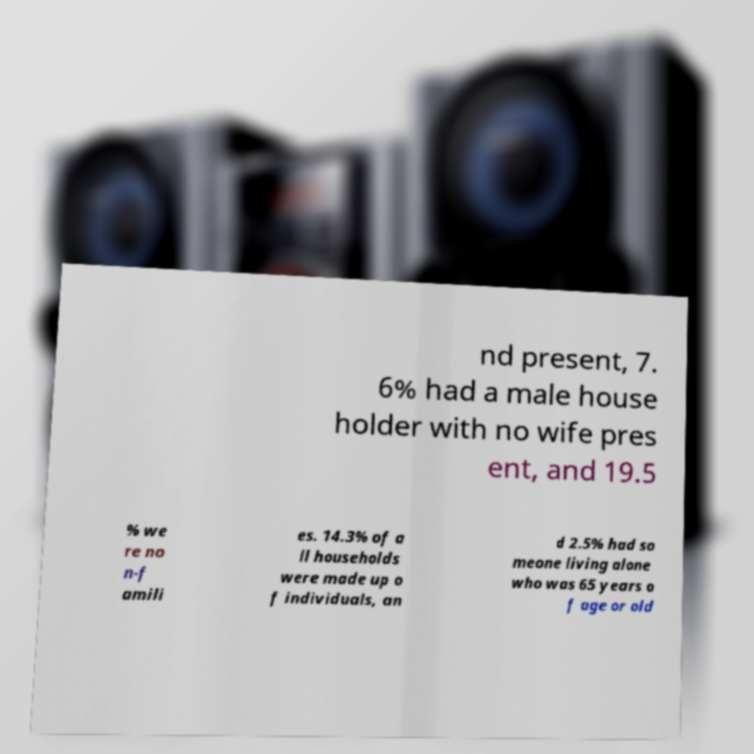Please identify and transcribe the text found in this image. nd present, 7. 6% had a male house holder with no wife pres ent, and 19.5 % we re no n-f amili es. 14.3% of a ll households were made up o f individuals, an d 2.5% had so meone living alone who was 65 years o f age or old 